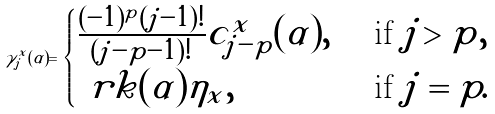<formula> <loc_0><loc_0><loc_500><loc_500>\gamma _ { j } ^ { x } ( \alpha ) = \begin{cases} \frac { ( - 1 ) ^ { p } ( j - 1 ) ! } { ( j - p - 1 ) ! } c _ { j - p } ^ { x } ( \alpha ) , & \ \text {if } j > p , \\ \ r k ( \alpha ) \eta _ { x } , & \ \text {if } j = p . \end{cases}</formula> 